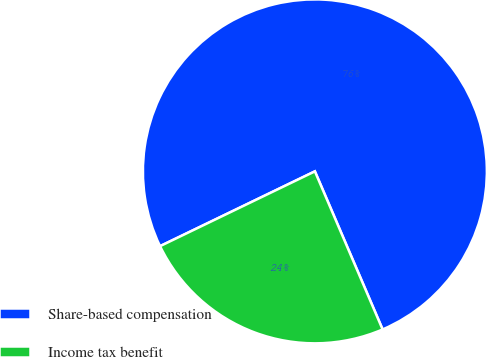Convert chart. <chart><loc_0><loc_0><loc_500><loc_500><pie_chart><fcel>Share-based compensation<fcel>Income tax benefit<nl><fcel>75.72%<fcel>24.28%<nl></chart> 